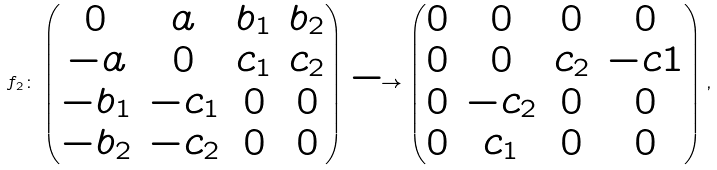Convert formula to latex. <formula><loc_0><loc_0><loc_500><loc_500>f _ { 2 } \colon \begin{pmatrix} 0 & a & b _ { 1 } & b _ { 2 } \\ - a & 0 & c _ { 1 } & c _ { 2 } \\ - b _ { 1 } & - c _ { 1 } & 0 & 0 \\ - b _ { 2 } & - c _ { 2 } & 0 & 0 \\ \end{pmatrix} \longrightarrow \begin{pmatrix} 0 & 0 & 0 & 0 \\ 0 & 0 & c _ { 2 } & - c 1 \\ 0 & - c _ { 2 } & 0 & 0 \\ 0 & c _ { 1 } & 0 & 0 \\ \end{pmatrix} ,</formula> 